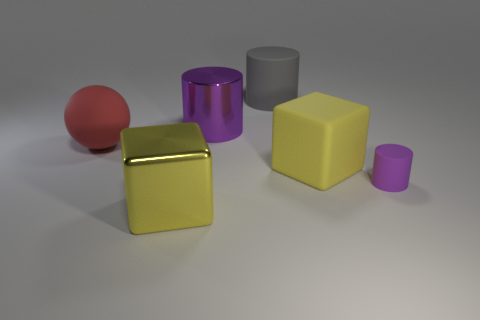Is the number of matte objects to the left of the large purple cylinder less than the number of purple rubber things behind the rubber cube?
Provide a short and direct response. No. There is a yellow shiny cube; does it have the same size as the matte cylinder that is on the left side of the yellow rubber object?
Provide a short and direct response. Yes. What is the shape of the thing that is both on the left side of the purple metal cylinder and on the right side of the red rubber thing?
Ensure brevity in your answer.  Cube. What size is the purple cylinder that is the same material as the large red thing?
Your response must be concise. Small. There is a yellow thing that is right of the large purple object; what number of big red spheres are in front of it?
Give a very brief answer. 0. Do the cube that is to the left of the yellow rubber cube and the gray cylinder have the same material?
Provide a succinct answer. No. What size is the cylinder that is behind the big cylinder in front of the big gray rubber object?
Ensure brevity in your answer.  Large. What size is the yellow thing on the right side of the rubber cylinder on the left side of the matte cylinder that is in front of the large purple cylinder?
Ensure brevity in your answer.  Large. Is the shape of the purple object on the right side of the big gray cylinder the same as the purple thing left of the tiny matte object?
Ensure brevity in your answer.  Yes. How many other things are the same color as the big metal cylinder?
Your answer should be compact. 1. 